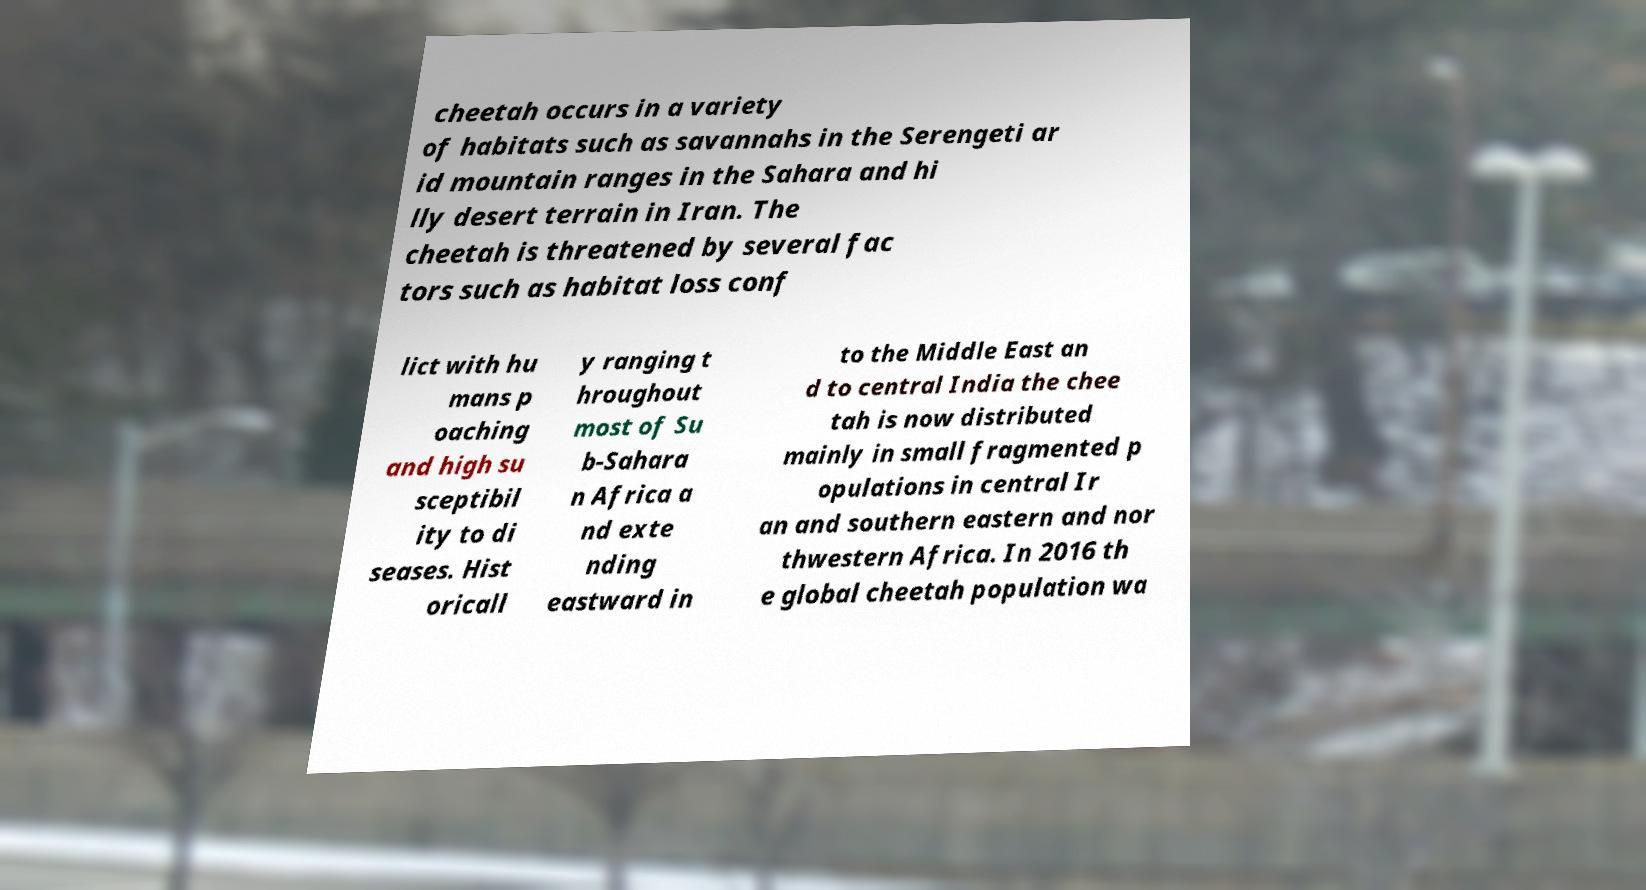Can you accurately transcribe the text from the provided image for me? cheetah occurs in a variety of habitats such as savannahs in the Serengeti ar id mountain ranges in the Sahara and hi lly desert terrain in Iran. The cheetah is threatened by several fac tors such as habitat loss conf lict with hu mans p oaching and high su sceptibil ity to di seases. Hist oricall y ranging t hroughout most of Su b-Sahara n Africa a nd exte nding eastward in to the Middle East an d to central India the chee tah is now distributed mainly in small fragmented p opulations in central Ir an and southern eastern and nor thwestern Africa. In 2016 th e global cheetah population wa 